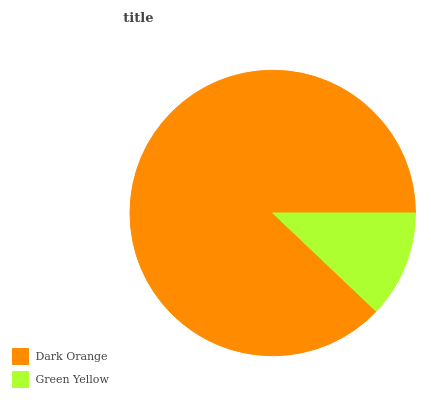Is Green Yellow the minimum?
Answer yes or no. Yes. Is Dark Orange the maximum?
Answer yes or no. Yes. Is Green Yellow the maximum?
Answer yes or no. No. Is Dark Orange greater than Green Yellow?
Answer yes or no. Yes. Is Green Yellow less than Dark Orange?
Answer yes or no. Yes. Is Green Yellow greater than Dark Orange?
Answer yes or no. No. Is Dark Orange less than Green Yellow?
Answer yes or no. No. Is Dark Orange the high median?
Answer yes or no. Yes. Is Green Yellow the low median?
Answer yes or no. Yes. Is Green Yellow the high median?
Answer yes or no. No. Is Dark Orange the low median?
Answer yes or no. No. 